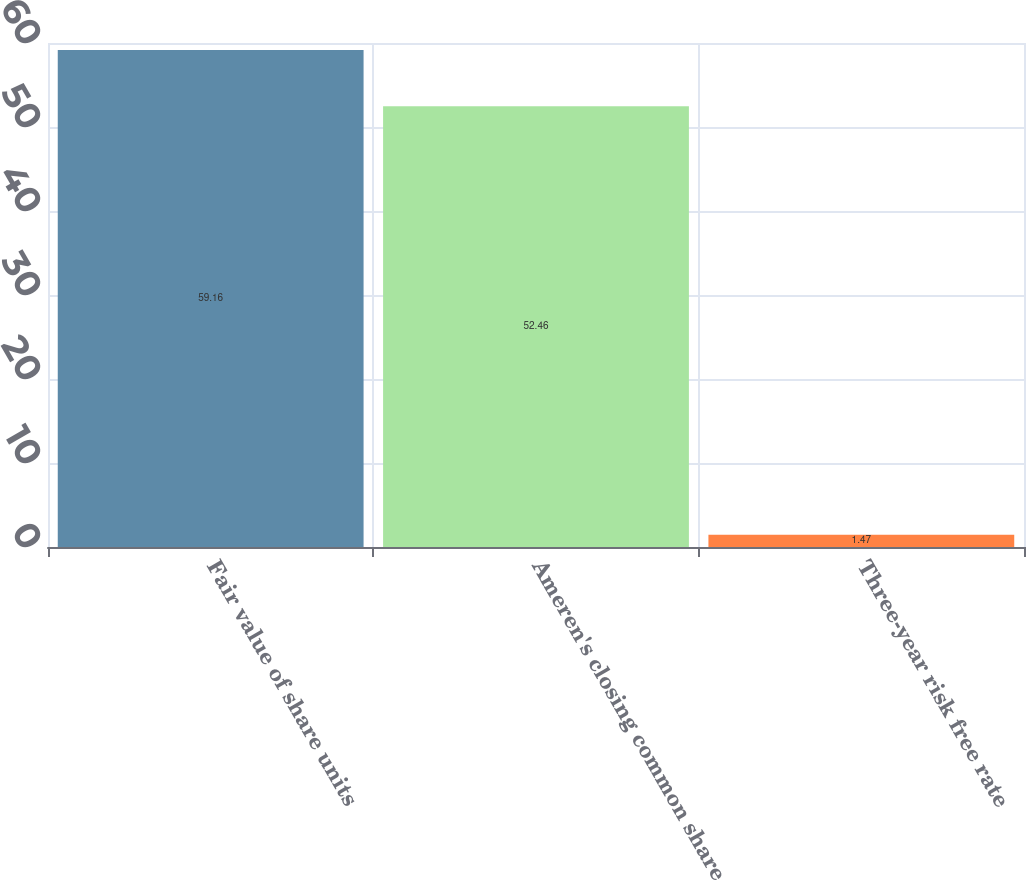Convert chart to OTSL. <chart><loc_0><loc_0><loc_500><loc_500><bar_chart><fcel>Fair value of share units<fcel>Ameren's closing common share<fcel>Three-year risk free rate<nl><fcel>59.16<fcel>52.46<fcel>1.47<nl></chart> 